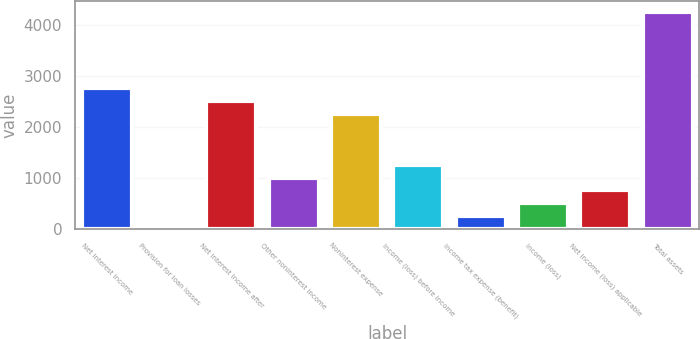<chart> <loc_0><loc_0><loc_500><loc_500><bar_chart><fcel>Net interest income<fcel>Provision for loan losses<fcel>Net interest income after<fcel>Other noninterest income<fcel>Noninterest expense<fcel>Income (loss) before income<fcel>Income tax expense (benefit)<fcel>Income (loss)<fcel>Net income (loss) applicable<fcel>Total assets<nl><fcel>2761.4<fcel>7<fcel>2511<fcel>1008.6<fcel>2260.6<fcel>1259<fcel>257.4<fcel>507.8<fcel>758.2<fcel>4263.8<nl></chart> 